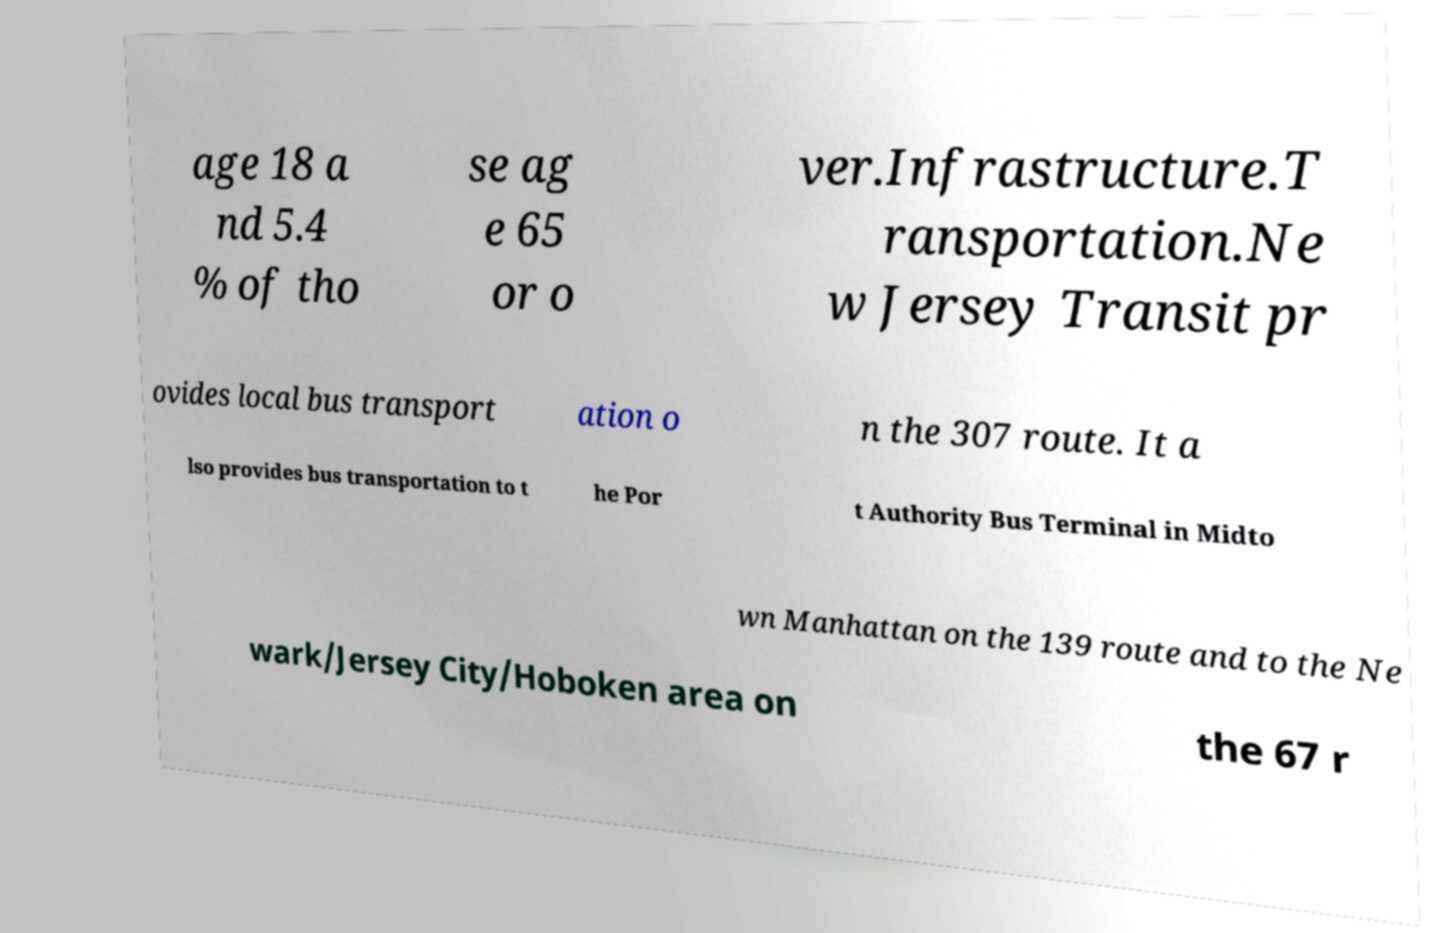For documentation purposes, I need the text within this image transcribed. Could you provide that? age 18 a nd 5.4 % of tho se ag e 65 or o ver.Infrastructure.T ransportation.Ne w Jersey Transit pr ovides local bus transport ation o n the 307 route. It a lso provides bus transportation to t he Por t Authority Bus Terminal in Midto wn Manhattan on the 139 route and to the Ne wark/Jersey City/Hoboken area on the 67 r 